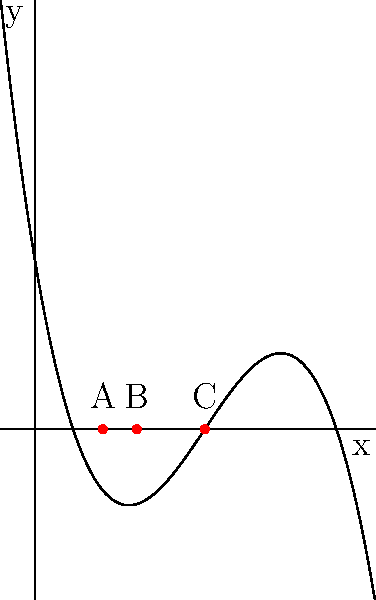In a new experimental ninepin bowling setup, the optimal placement of pins is determined by the roots of a polynomial equation. The equation $f(x) = -0.1x^3 + 1.5x^2 - 6x + 5$ represents the trajectory of the bowling ball, where $x$ is the distance from the starting point in meters. The roots of this equation correspond to potential pin positions. What is the sum of these optimal pin positions (rounded to the nearest whole number)? To solve this problem, we need to follow these steps:

1) First, we need to find the roots of the equation $f(x) = -0.1x^3 + 1.5x^2 - 6x + 5 = 0$

2) The graph shows that there are three roots, labeled as points A, B, and C.

3) To find these roots precisely, we can use the quadratic formula or a graphing calculator. The roots are:
   
   $x_1 \approx 2$ (point A)
   $x_2 \approx 3$ (point B)
   $x_3 \approx 5$ (point C)

4) The sum of these roots is: $2 + 3 + 5 = 10$

5) The question asks for the sum rounded to the nearest whole number, but 10 is already a whole number.

Therefore, the sum of the optimal pin positions is 10 meters from the starting point.
Answer: 10 meters 